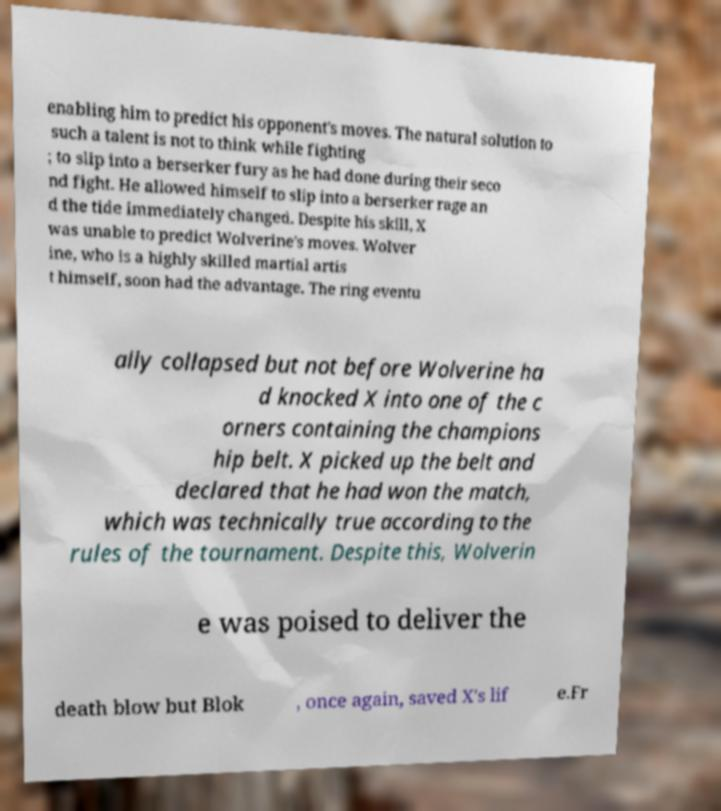Can you accurately transcribe the text from the provided image for me? enabling him to predict his opponent's moves. The natural solution to such a talent is not to think while fighting ; to slip into a berserker fury as he had done during their seco nd fight. He allowed himself to slip into a berserker rage an d the tide immediately changed. Despite his skill, X was unable to predict Wolverine's moves. Wolver ine, who is a highly skilled martial artis t himself, soon had the advantage. The ring eventu ally collapsed but not before Wolverine ha d knocked X into one of the c orners containing the champions hip belt. X picked up the belt and declared that he had won the match, which was technically true according to the rules of the tournament. Despite this, Wolverin e was poised to deliver the death blow but Blok , once again, saved X's lif e.Fr 